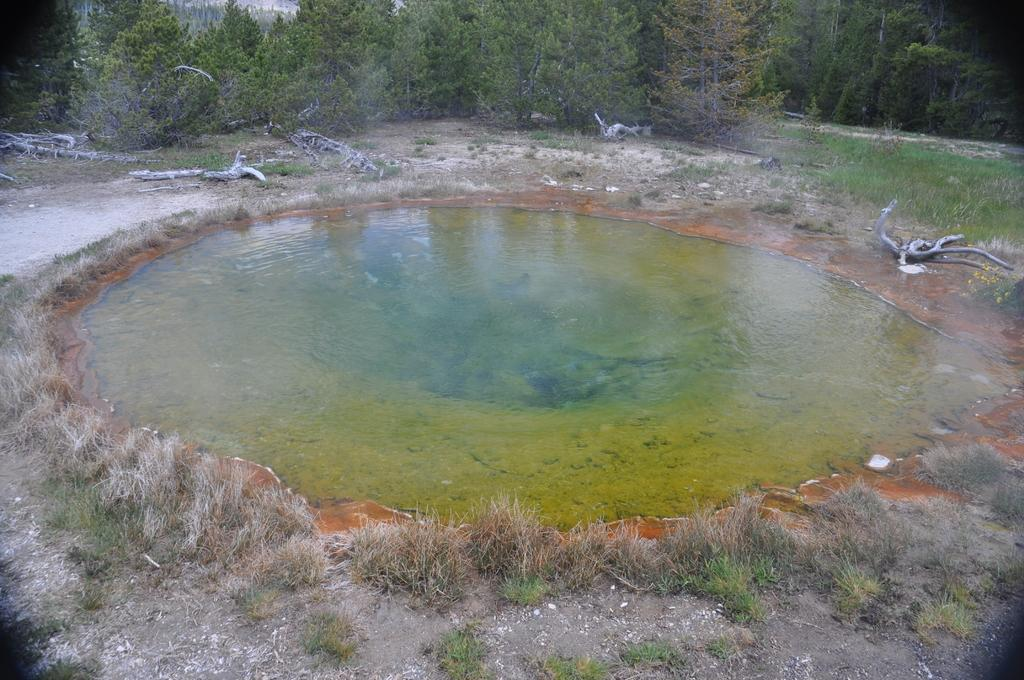What is the main feature in the center of the image? There is a water pond in the center of the image. What type of vegetation surrounds the water pond? Grass is present around the water pond. What can be seen near the water pond? There are dried trunks of trees near the water pond. What is visible in the background of the image? Trees are visible at the top of the image. Where is the hospital located in the image? There is no hospital present in the image. What type of pet can be seen playing near the water pond? There are no pets visible in the image; it features a water pond, grass, dried tree trunks, and trees in the background. 